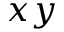<formula> <loc_0><loc_0><loc_500><loc_500>x y</formula> 